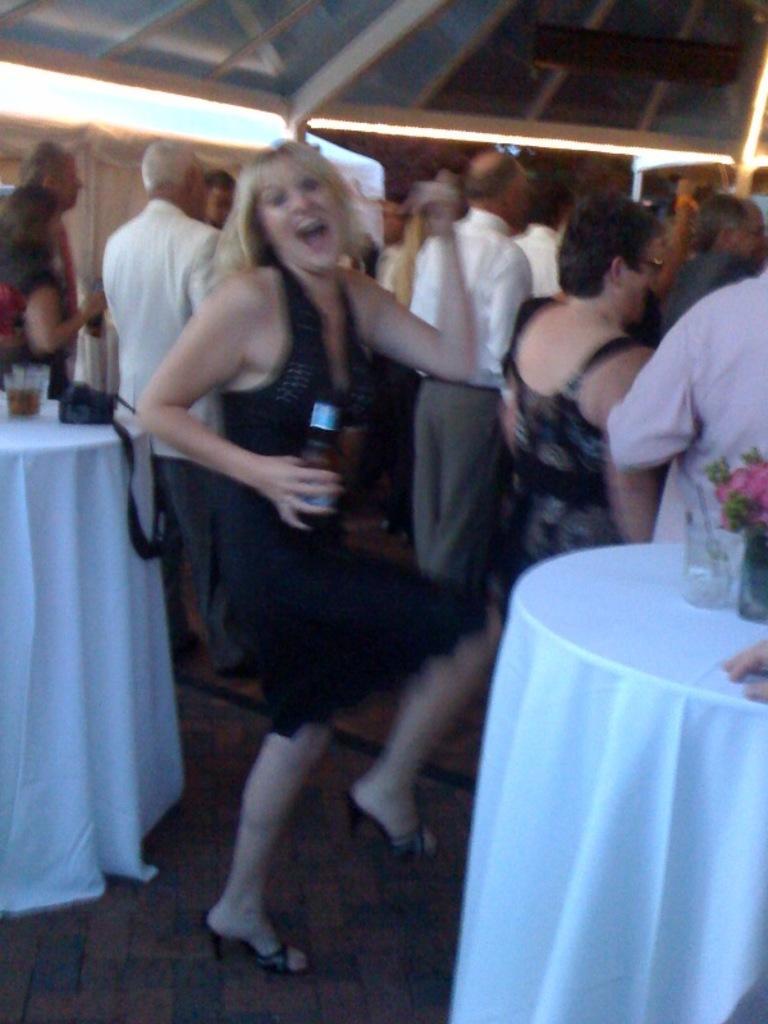In one or two sentences, can you explain what this image depicts? In this picture I can see there is a woman dancing and she is holding a beer bottle, she is wearing a black dress and there few people standing in the backdrop and there are two tables at left and right. There are few flowers placed on the table. 